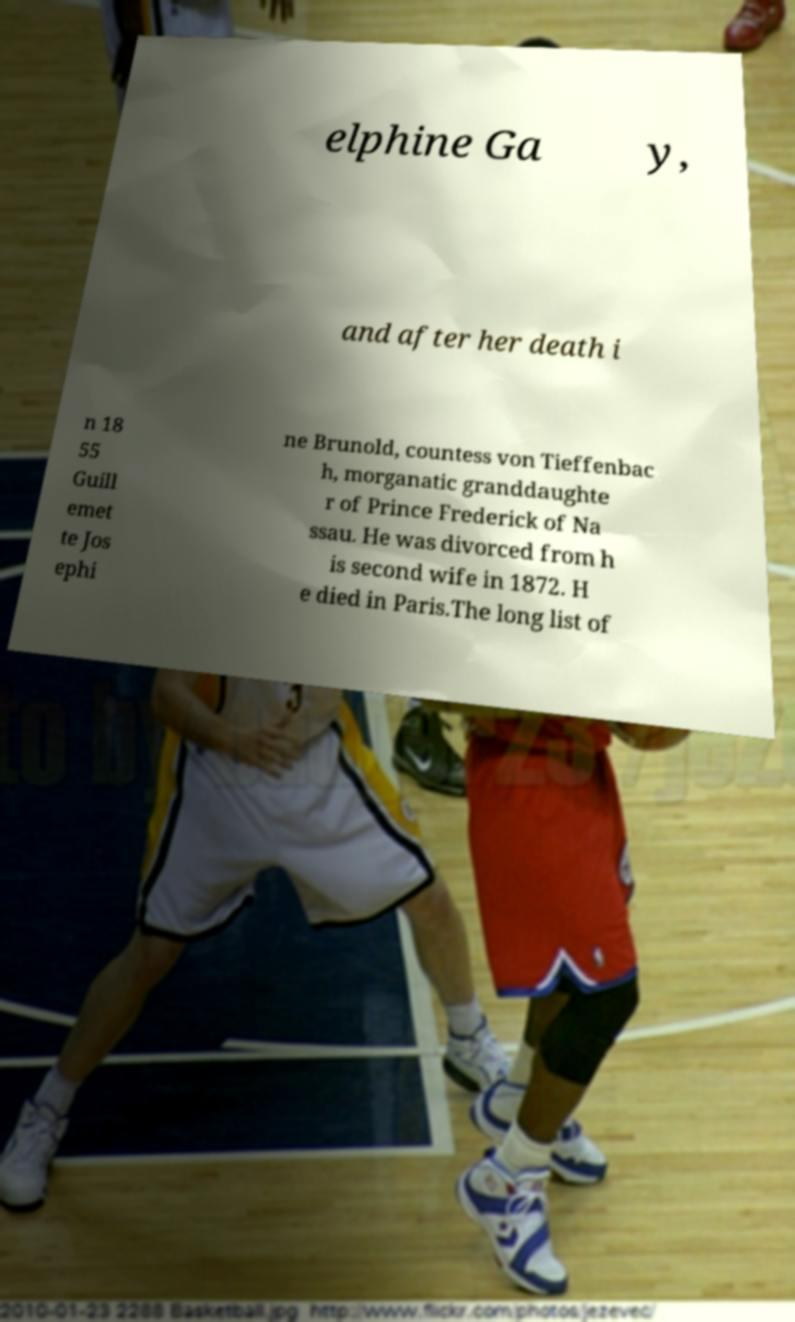For documentation purposes, I need the text within this image transcribed. Could you provide that? elphine Ga y, and after her death i n 18 55 Guill emet te Jos ephi ne Brunold, countess von Tieffenbac h, morganatic granddaughte r of Prince Frederick of Na ssau. He was divorced from h is second wife in 1872. H e died in Paris.The long list of 